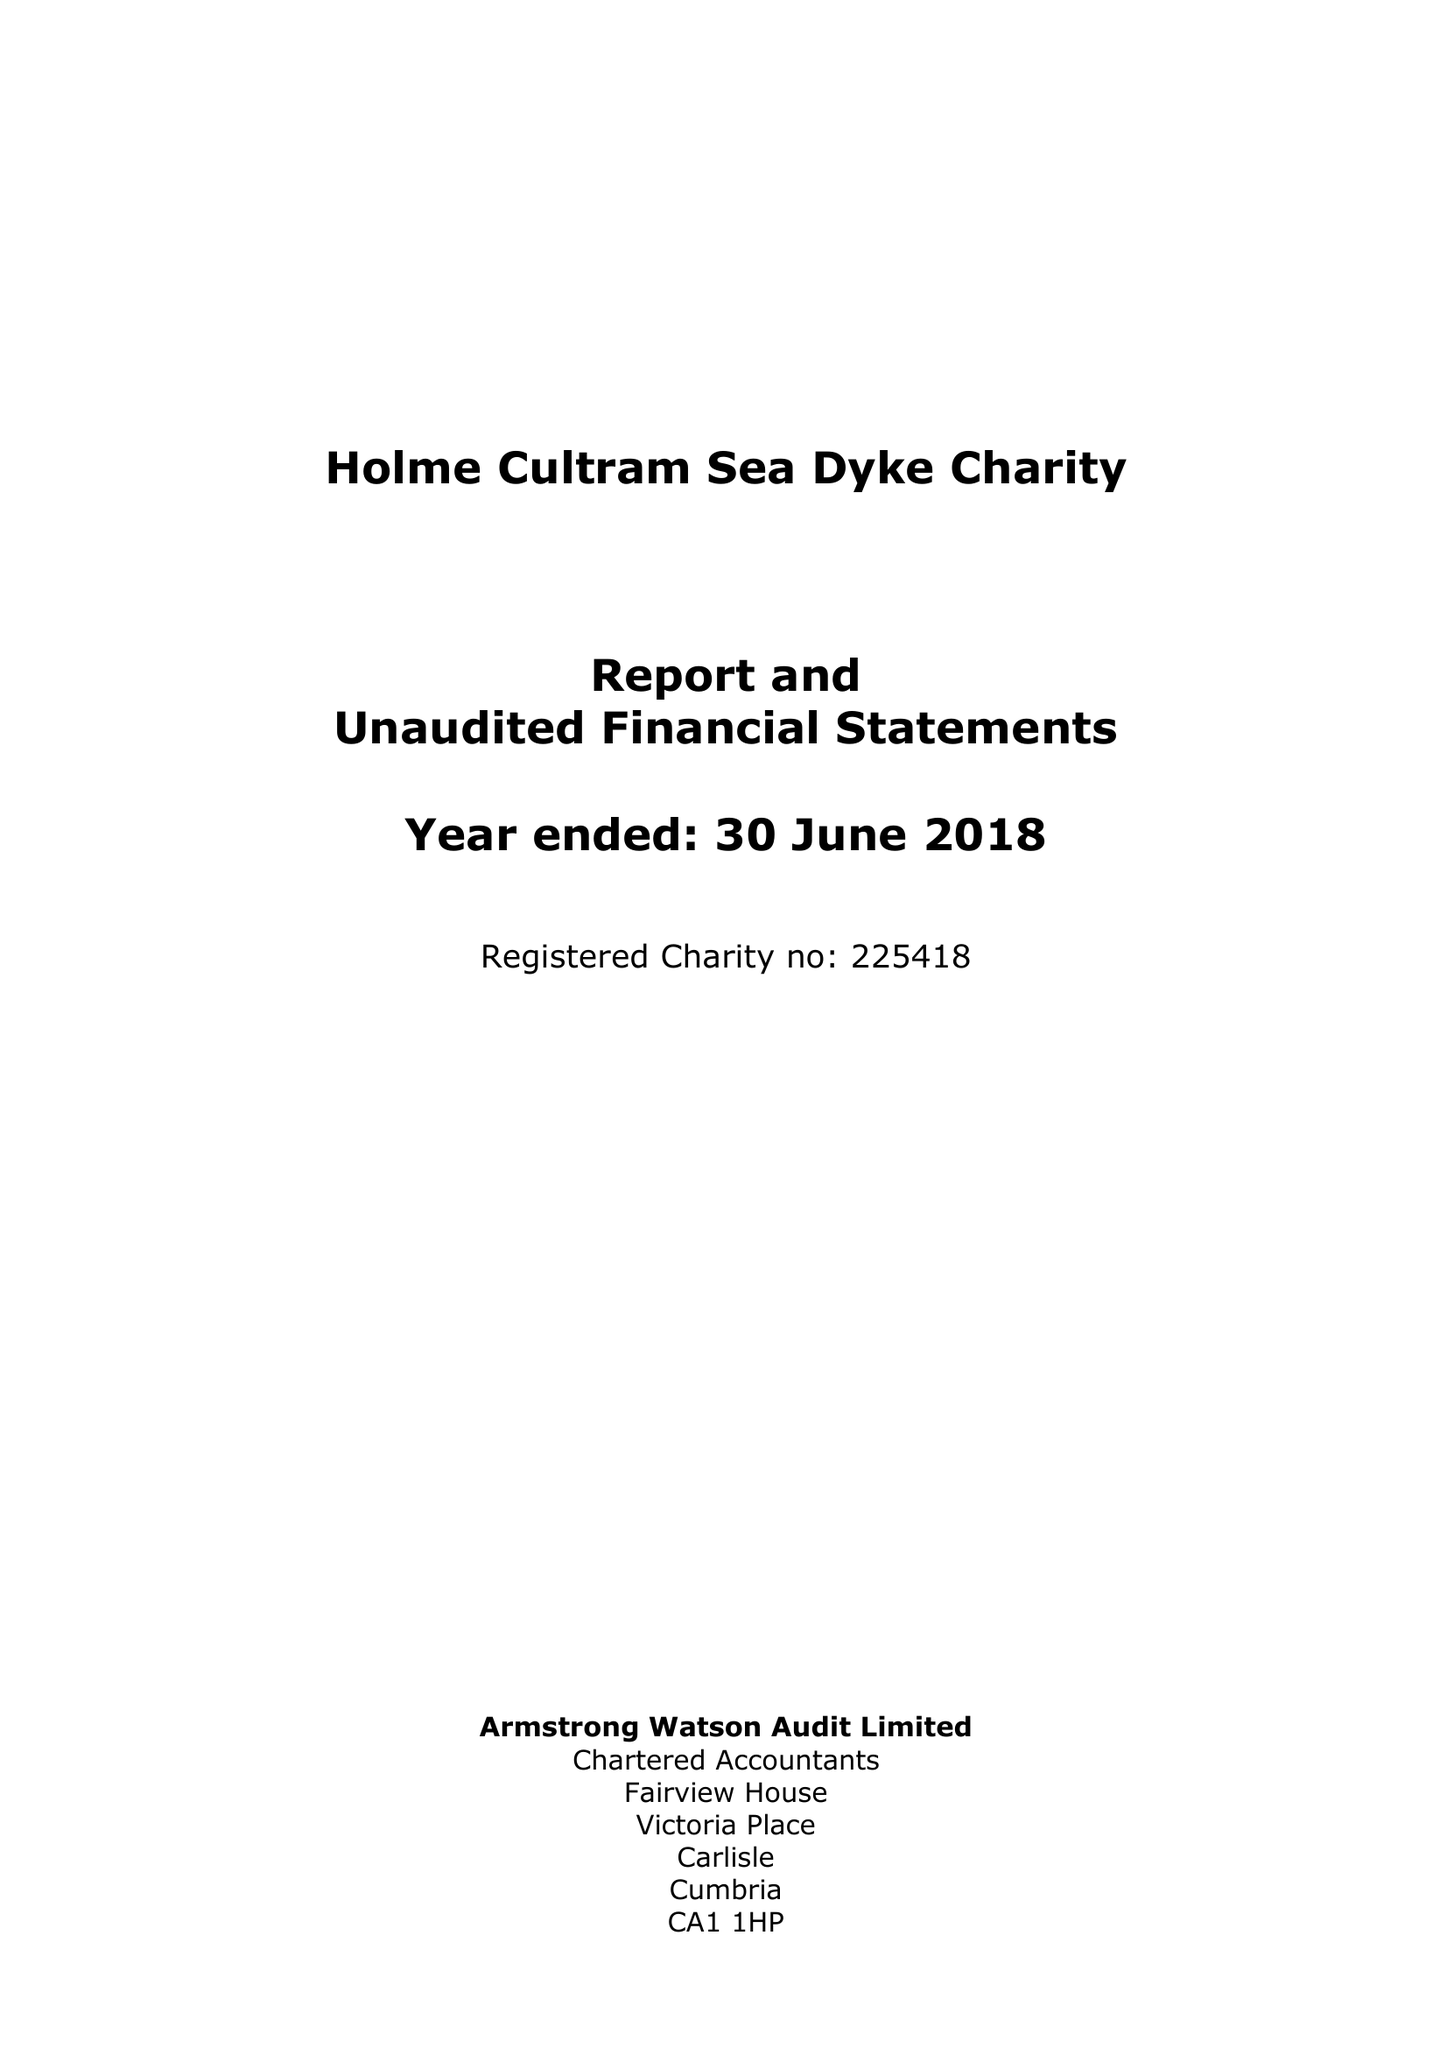What is the value for the spending_annually_in_british_pounds?
Answer the question using a single word or phrase. 39859.00 